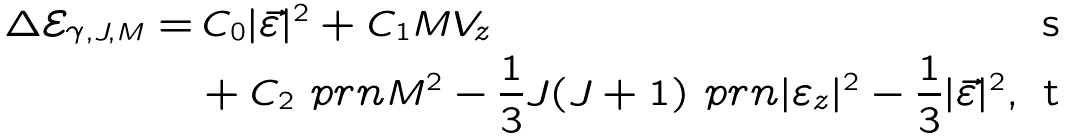<formula> <loc_0><loc_0><loc_500><loc_500>\Delta \mathcal { E } _ { \gamma , J , M } = & \, C _ { 0 } | \vec { \varepsilon } | ^ { 2 } + C _ { 1 } M V _ { z } \\ & + C _ { 2 } \ p r n { M ^ { 2 } - \frac { 1 } { 3 } J ( J + 1 ) } \ p r n { | \varepsilon _ { z } | ^ { 2 } - \frac { 1 } { 3 } | \vec { \varepsilon } | ^ { 2 } } ,</formula> 